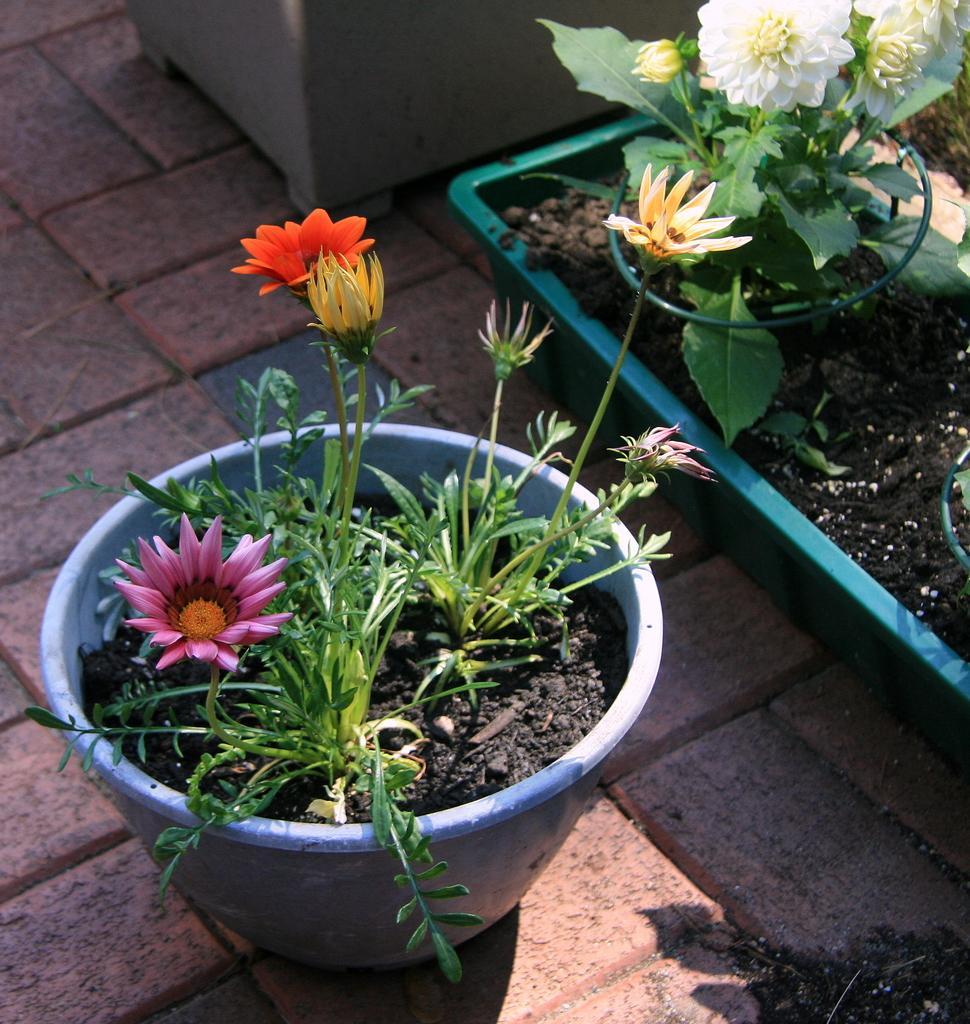Describe this image in one or two sentences. This picture is clicked outside. In the center we can see the house plants containing different colors of flowers. In the background there is a pavement and a pot. 